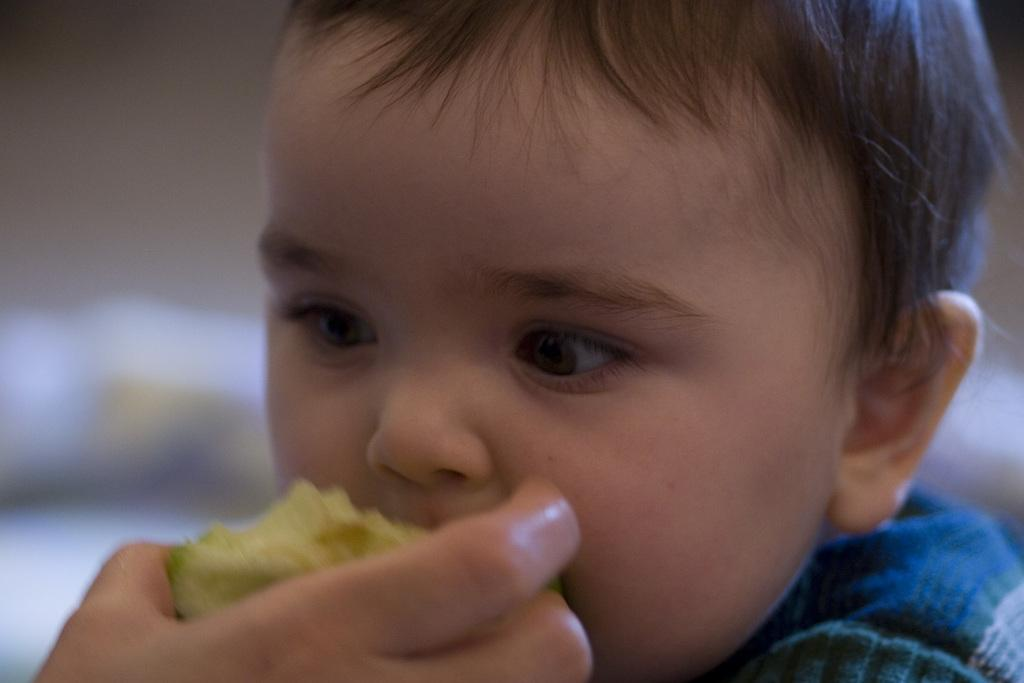Who is the main subject in the image? There is a boy in the image. What is the boy wearing? The boy is wearing a blue t-shirt. Can you describe the person in the bottom left of the image? There is a person holding an apple in the bottom left of the image. What type of parcel is being delivered to the boy in the image? There is no parcel being delivered to the boy in the image. Can you describe the power source for the apple in the image? There is no power source for the apple in the image, as it is a fruit and not an electronic device. 